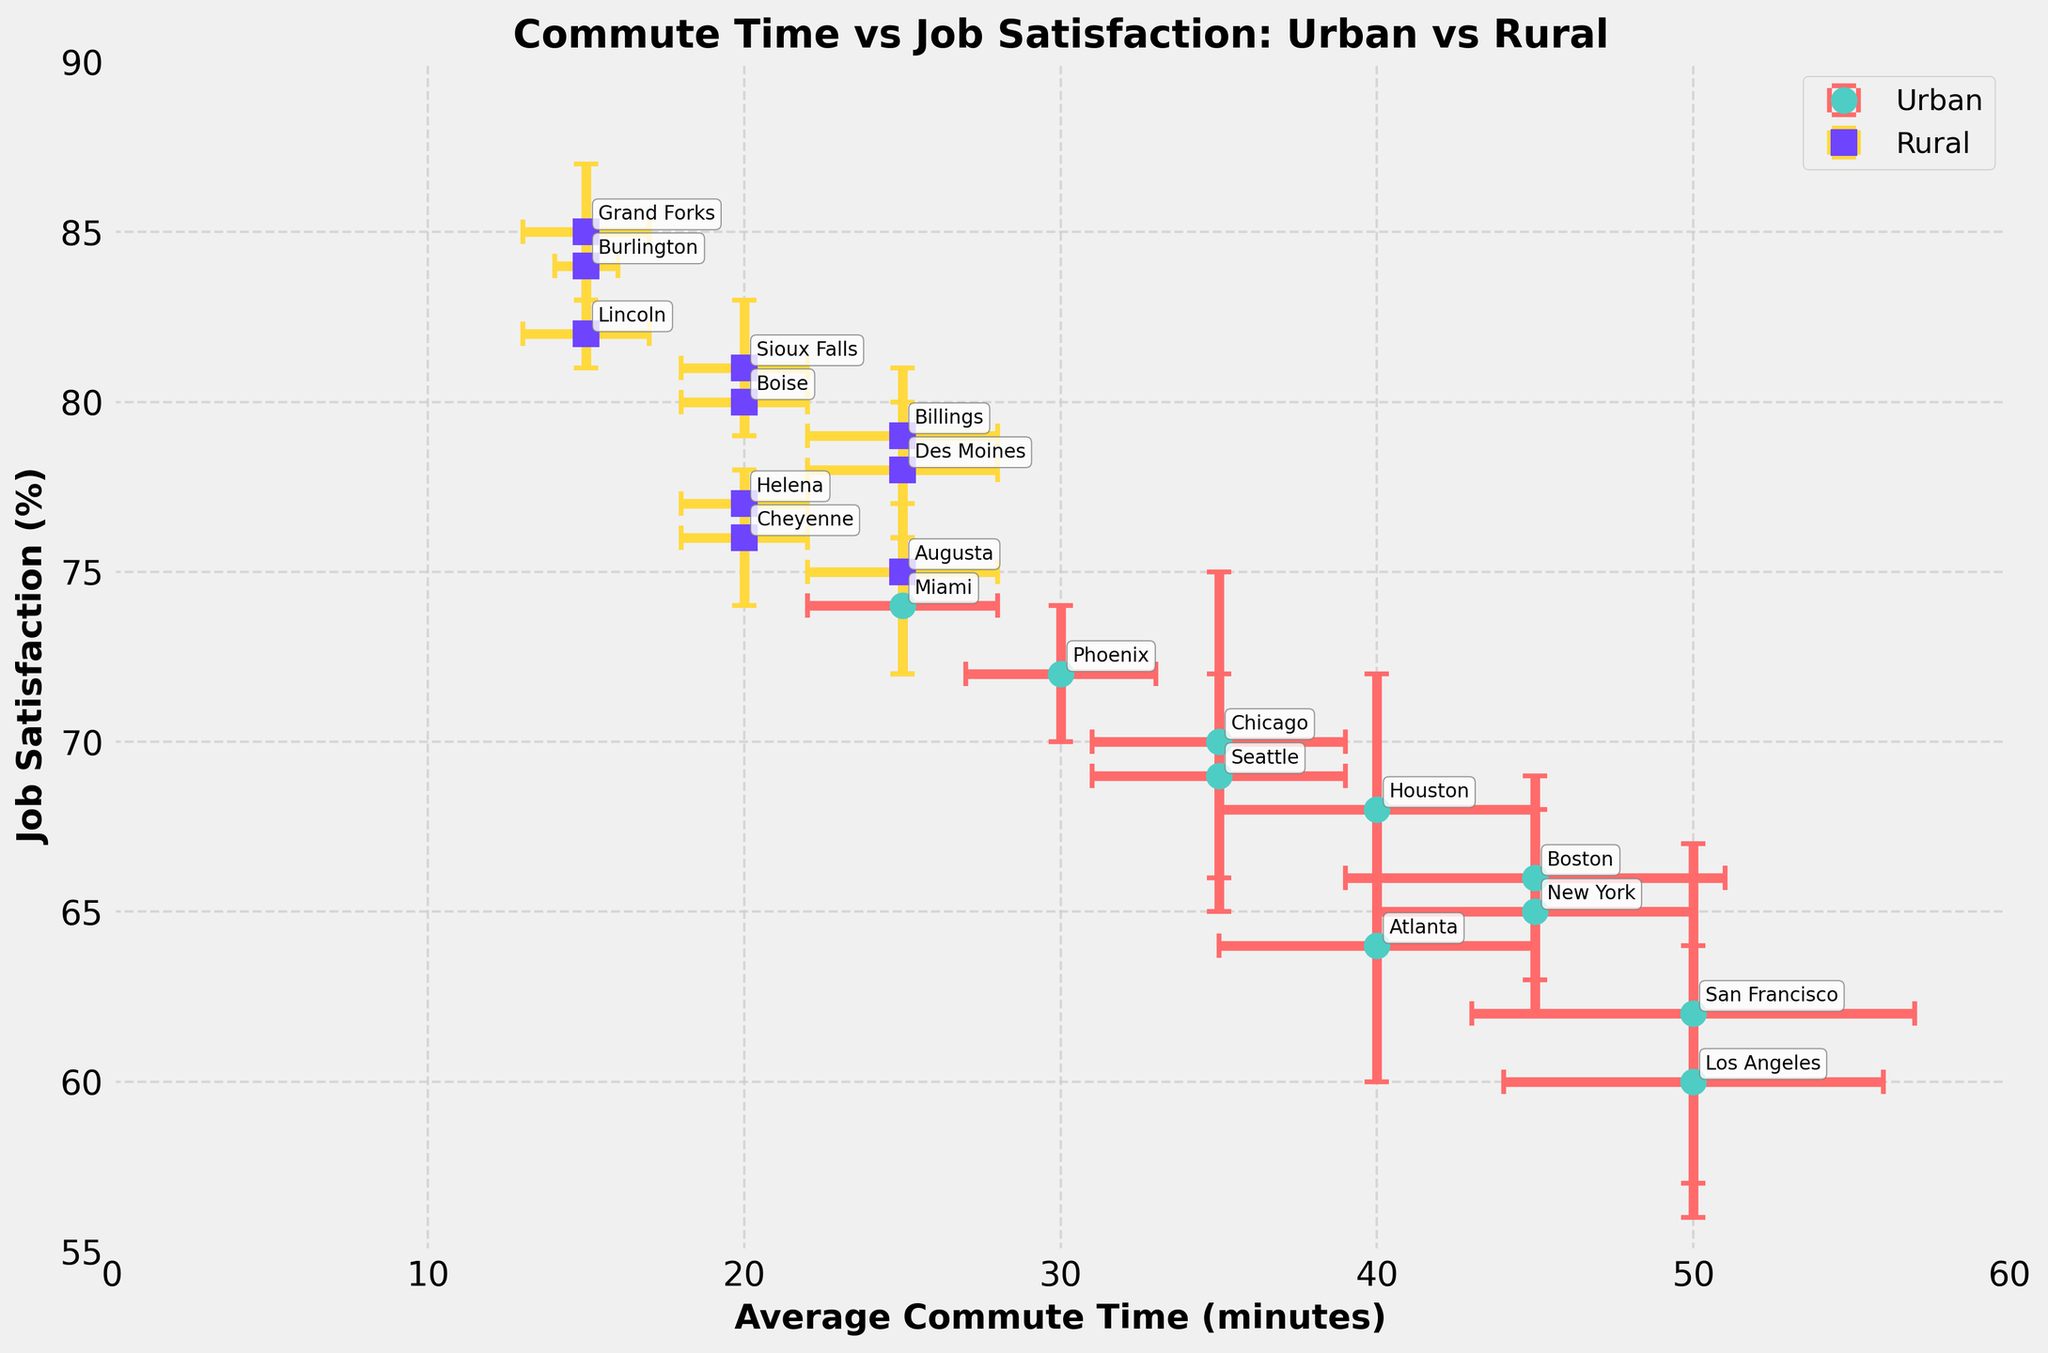what is the title of the figure? The title is clearly labeled at the top of the figure. It provides a summary of what the plot represents.
Answer: Commute Time vs Job Satisfaction: Urban vs Rural How many urban data points are shown in the plot? Urban areas are represented with circular markers on the plot. Counting these markers gives us the number of urban data points.
Answer: 10 Which city has the lowest job satisfaction percentage? By looking at the vertical axis, we can determine the job satisfaction percentages. Identify the lowest job satisfaction data point and refer to the corresponding city label.
Answer: Los Angeles What is the average job satisfaction for rural areas? Locate all rural data points, which are represented by square markers. Sum up their job satisfaction percentages and divide by the number of rural data points.
Answer: 80.7 Which area type generally has higher job satisfaction? Compare the vertical positioning of urban and rural data points to determine which set is higher on average.
Answer: Rural Which city has the highest commute time and how much is the error in that time? Locate the data point with the highest value on the horizontal axis. Then, read off its error bars on the x-axis.
Answer: Los Angeles, 6 minutes Is there any overlap in the error bars for commute times between New York and Los Angeles? Check the error bars around the commute times for New York and Los Angeles. See if the bars touch or overlap.
Answer: No What is the range in job satisfaction for rural areas? Find the maximum and minimum job satisfaction percentages for rural areas and calculate the difference.
Answer: 9% Which city has the smallest commute time among urban areas and what is its job satisfaction rate? Identify the urban data point farthest to the left on the horizontal axis (smallest x-value). Read off its corresponding job satisfaction from the vertical axis.
Answer: Miami, 74% In general, how do commute times relate to job satisfaction based on the plot? Analyze the placement of data points on the plot to infer the relationship between commute times and job satisfaction.
Answer: Shorter commute times tend to correlate with higher job satisfaction 